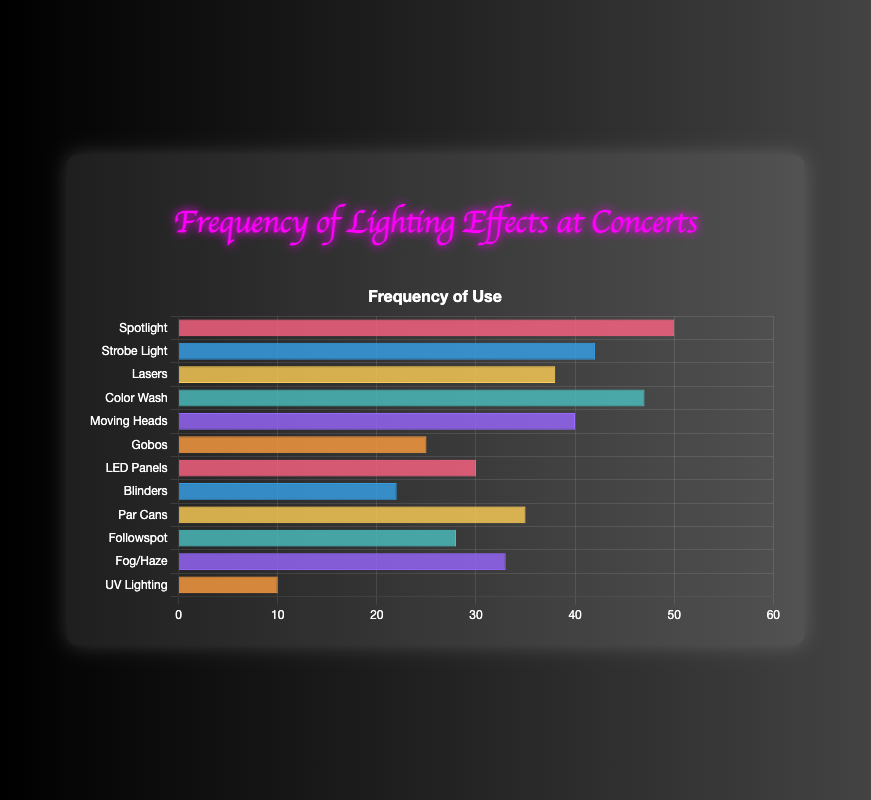Which lighting effect is used most frequently at concerts? The highest bar in the chart represents the lighting effect used most frequently. The Spotlight bar is the highest.
Answer: Spotlight What is the frequency difference between the most and least frequently used lighting effects? The most frequently used effect is Spotlight with a frequency of 50, and the least frequently used effect is UV Lighting with a frequency of 10. The difference is 50 - 10.
Answer: 40 What's the combined frequency of Gobos and Followspot lighting effects? Gobos have a frequency of 25, and Followspot has a frequency of 28. Their combined frequency is 25 + 28.
Answer: 53 Which lighting effects have frequencies equal to or greater than 40? By looking at frequency values and comparing them to 40, the effects with frequencies equal to or greater than 40 are Spotlight (50), Strobe Light (42), Color Wash (47), and Moving Heads (40).
Answer: Spotlight, Strobe Light, Color Wash, Moving Heads How many lighting effects have a frequency exceeding 30 but below 50? The frequencies of the effects are: Lasers (38), Gobos (25), LED Panels (30), Blinders (22), Par Cans (35), Followspot (28), Fog/Haze (33), and UV Lighting (10). Selecting the ones that exceed 30 but are below 50, we get Lasers (38), Color Wash (47), and Par Cans (35).
Answer: 3 What is the average frequency of Strobe Light, Moving Heads, and Followspot lighting effects? The frequencies are Strobe Light (42), Moving Heads (40), and Followspot (28). Their average is calculated as (42 + 40 + 28) / 3 = 110 / 3 ≈ 36.67.
Answer: 36.67 Which lighting effect has a bar color matching that of Strobe Light? By examining the chart, the Strobe Light bar is blue. Another effect with the same blue-colored bar is Blinders.
Answer: Blinders What is the visual difference between the bars representing UV Lighting and Fog/Haze? Comparing the lengths, the UV Lighting bar (with a frequency of 10) is significantly shorter than the Fog/Haze bar (with a frequency of 33). Also, UV Lighting is in orange while Fog/Haze is in purple.
Answer: UV Lighting is shorter and orange; Fog/Haze is longer and purple If Spotlight and Color Wash are combined, what would be their total frequency? The frequency of Spotlight is 50 and Color Wash is 47. Their combined frequency is 50 + 47.
Answer: 97 Which lighting effects have a frequency within 5 units of the frequency of Lasers? Lasers have a frequency of 38. Effects with frequencies within 5 units are Strobe Light (42) and Moving Heads (40), as they are 4 and 2 units away respectively.
Answer: Strobe Light, Moving Heads 